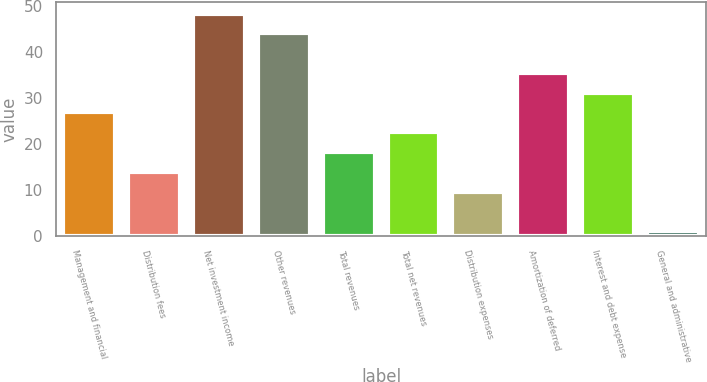Convert chart to OTSL. <chart><loc_0><loc_0><loc_500><loc_500><bar_chart><fcel>Management and financial<fcel>Distribution fees<fcel>Net investment income<fcel>Other revenues<fcel>Total revenues<fcel>Total net revenues<fcel>Distribution expenses<fcel>Amortization of deferred<fcel>Interest and debt expense<fcel>General and administrative<nl><fcel>26.8<fcel>13.9<fcel>48.3<fcel>44<fcel>18.2<fcel>22.5<fcel>9.6<fcel>35.4<fcel>31.1<fcel>1<nl></chart> 